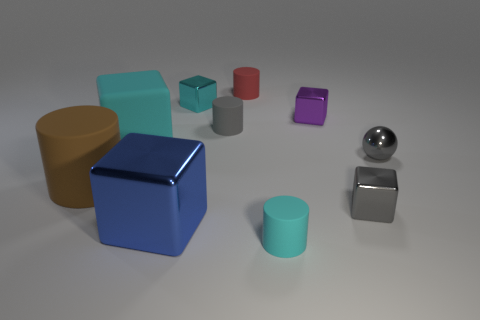Is there a yellow metallic cylinder that has the same size as the cyan rubber cylinder?
Offer a terse response. No. There is a ball; is it the same color as the small object that is in front of the tiny gray cube?
Offer a terse response. No. What is the material of the tiny red cylinder?
Ensure brevity in your answer.  Rubber. The rubber thing that is behind the purple object is what color?
Your answer should be very brief. Red. What number of tiny objects are the same color as the large shiny object?
Offer a terse response. 0. What number of metallic objects are to the left of the small cyan shiny object and on the right side of the gray metallic cube?
Offer a terse response. 0. There is a purple thing that is the same size as the cyan metal cube; what is its shape?
Your answer should be very brief. Cube. What size is the cyan metal object?
Keep it short and to the point. Small. What is the material of the cyan cube that is in front of the gray thing that is left of the small cylinder right of the small red rubber object?
Ensure brevity in your answer.  Rubber. The big block that is the same material as the tiny purple cube is what color?
Offer a terse response. Blue. 